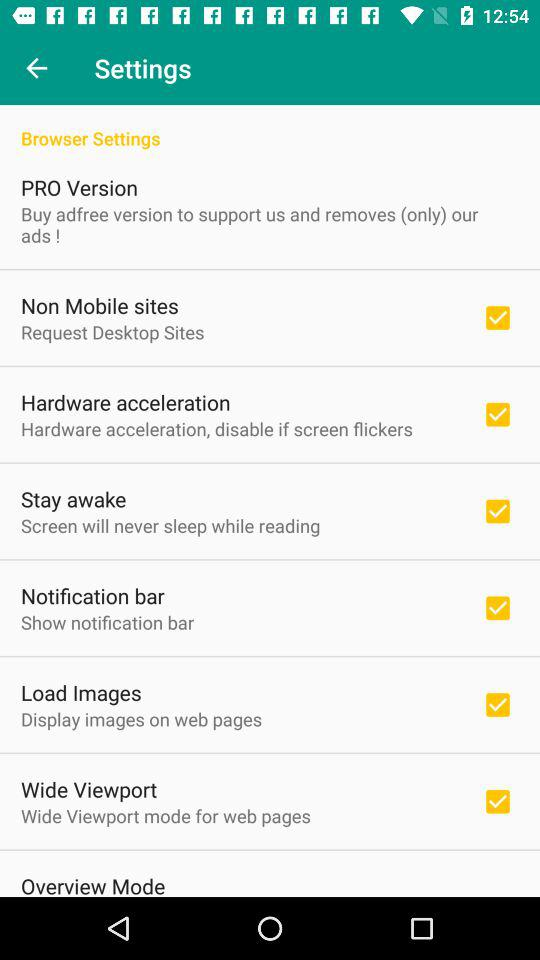What is the status of the notification bar setting option? The status is on. 